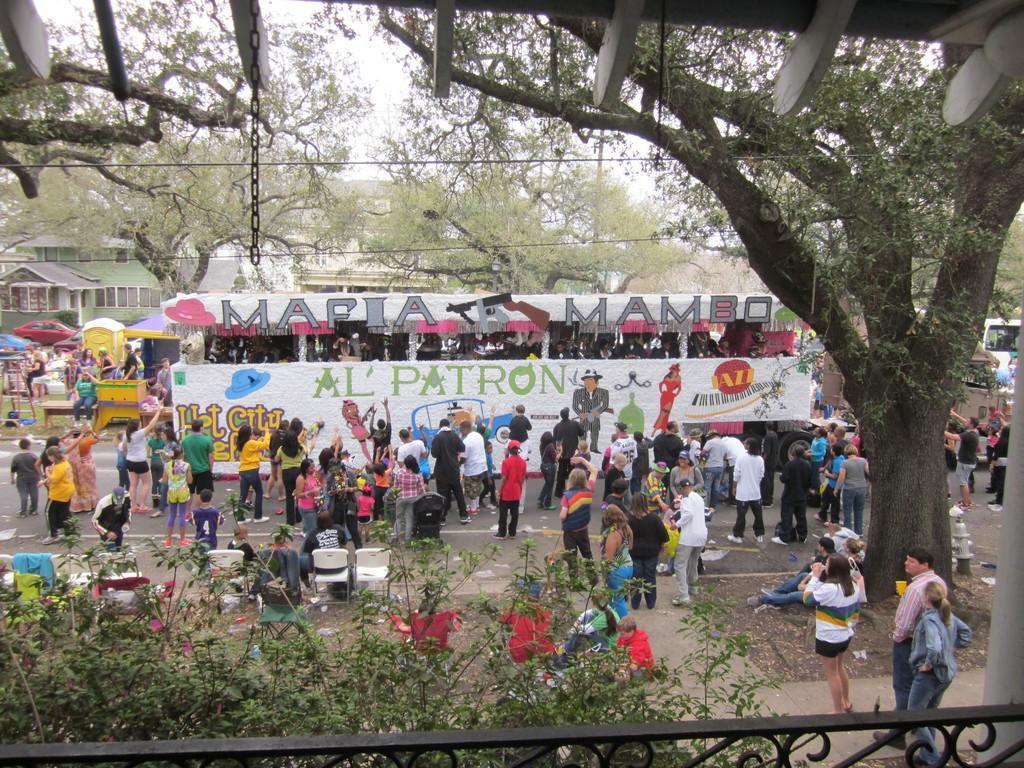How would you summarize this image in a sentence or two? In this image I can see number of trees, buildings and I can see number of people are standing. I can also see few white colour chairs and here I can see something is written on white colour thing. 